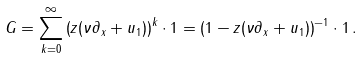Convert formula to latex. <formula><loc_0><loc_0><loc_500><loc_500>G = \sum _ { k = 0 } ^ { \infty } \left ( z ( \nu \partial _ { x } + u _ { 1 } ) \right ) ^ { k } \cdot 1 = \left ( 1 - z ( \nu \partial _ { x } + u _ { 1 } ) \right ) ^ { - 1 } \cdot 1 \, .</formula> 